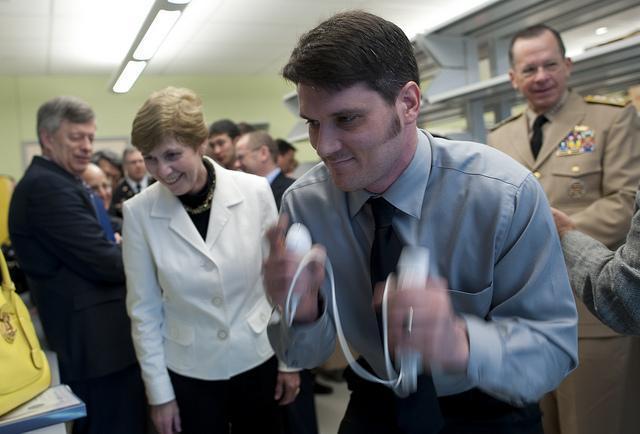What is the hair on the side of the man's cheek called?
Select the accurate response from the four choices given to answer the question.
Options: Sideburn, mustache, soul patch, goatee. Sideburn. 